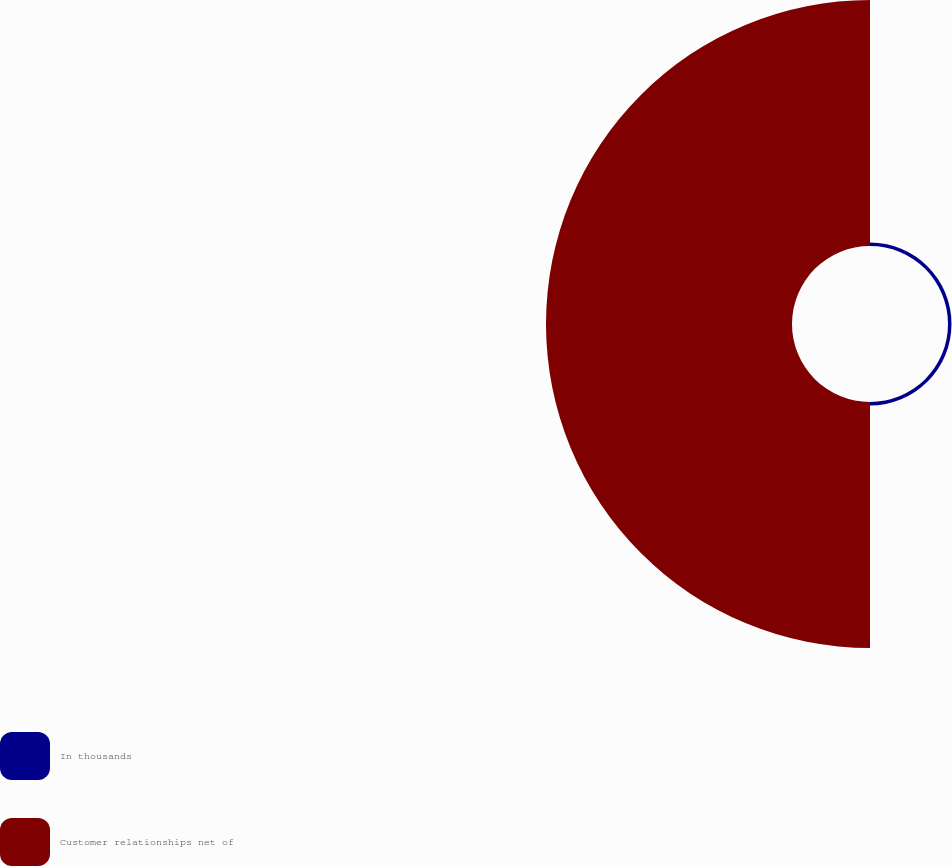<chart> <loc_0><loc_0><loc_500><loc_500><pie_chart><fcel>In thousands<fcel>Customer relationships net of<nl><fcel>1.4%<fcel>98.6%<nl></chart> 